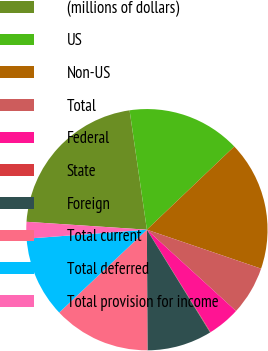<chart> <loc_0><loc_0><loc_500><loc_500><pie_chart><fcel>(millions of dollars)<fcel>US<fcel>Non-US<fcel>Total<fcel>Federal<fcel>State<fcel>Foreign<fcel>Total current<fcel>Total deferred<fcel>Total provision for income<nl><fcel>21.66%<fcel>15.18%<fcel>17.34%<fcel>6.54%<fcel>4.38%<fcel>0.07%<fcel>8.7%<fcel>13.02%<fcel>10.86%<fcel>2.23%<nl></chart> 